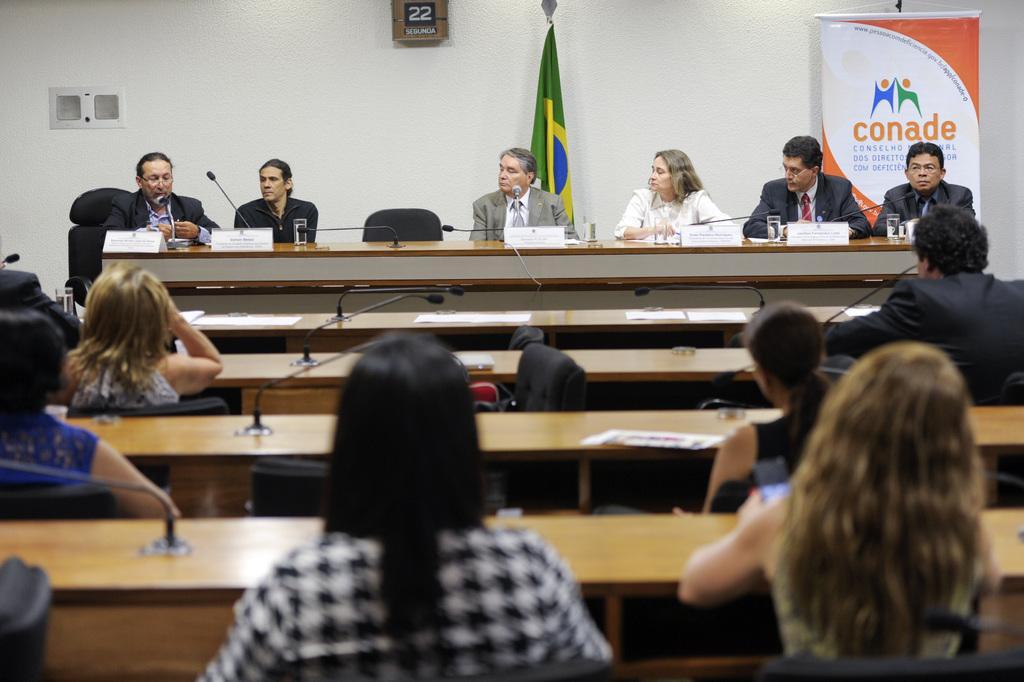How would you summarize this image in a sentence or two? In this image i can see group of people sitting on chair. On the table we can see a couple of microphone and glass of water in front of people. In the background there is a white color wall and here we have a flag and a banner. 